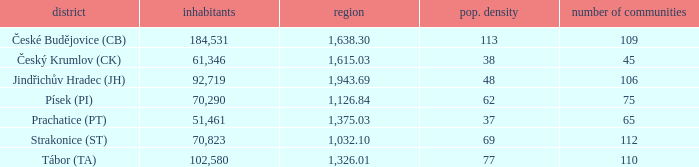How many settlements are in český krumlov (ck) with a population density higher than 38? None. Could you help me parse every detail presented in this table? {'header': ['district', 'inhabitants', 'region', 'pop. density', 'number of communities'], 'rows': [['České Budějovice (CB)', '184,531', '1,638.30', '113', '109'], ['Český Krumlov (CK)', '61,346', '1,615.03', '38', '45'], ['Jindřichův Hradec (JH)', '92,719', '1,943.69', '48', '106'], ['Písek (PI)', '70,290', '1,126.84', '62', '75'], ['Prachatice (PT)', '51,461', '1,375.03', '37', '65'], ['Strakonice (ST)', '70,823', '1,032.10', '69', '112'], ['Tábor (TA)', '102,580', '1,326.01', '77', '110']]} 